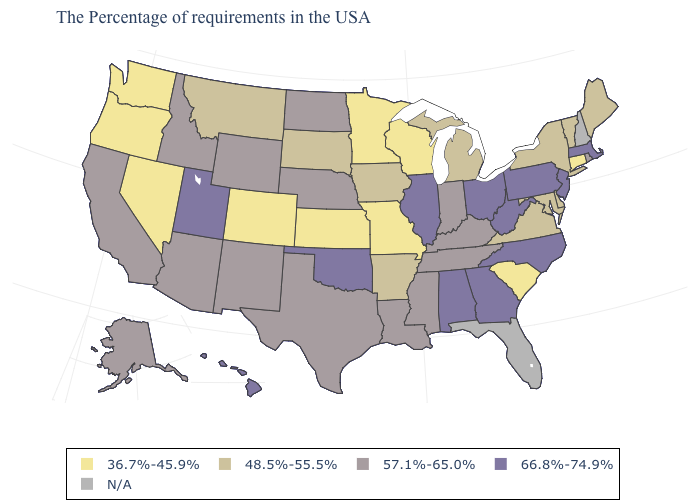What is the lowest value in the West?
Write a very short answer. 36.7%-45.9%. Which states have the lowest value in the USA?
Be succinct. Connecticut, South Carolina, Wisconsin, Missouri, Minnesota, Kansas, Colorado, Nevada, Washington, Oregon. What is the value of Hawaii?
Keep it brief. 66.8%-74.9%. What is the value of North Dakota?
Keep it brief. 57.1%-65.0%. What is the highest value in the Northeast ?
Short answer required. 66.8%-74.9%. Is the legend a continuous bar?
Quick response, please. No. Among the states that border New York , does Massachusetts have the highest value?
Keep it brief. Yes. What is the value of Connecticut?
Give a very brief answer. 36.7%-45.9%. Does the first symbol in the legend represent the smallest category?
Write a very short answer. Yes. Does South Carolina have the lowest value in the South?
Short answer required. Yes. What is the lowest value in the MidWest?
Short answer required. 36.7%-45.9%. Among the states that border New Hampshire , does Massachusetts have the highest value?
Keep it brief. Yes. Does South Carolina have the lowest value in the South?
Keep it brief. Yes. 